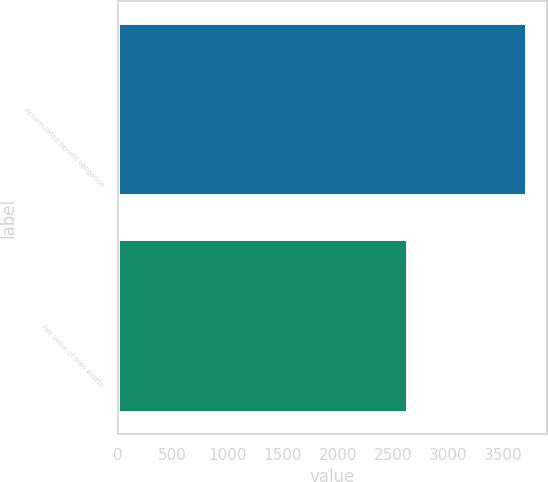<chart> <loc_0><loc_0><loc_500><loc_500><bar_chart><fcel>Accumulated benefit obligation<fcel>Fair value of plan assets<nl><fcel>3715<fcel>2633<nl></chart> 